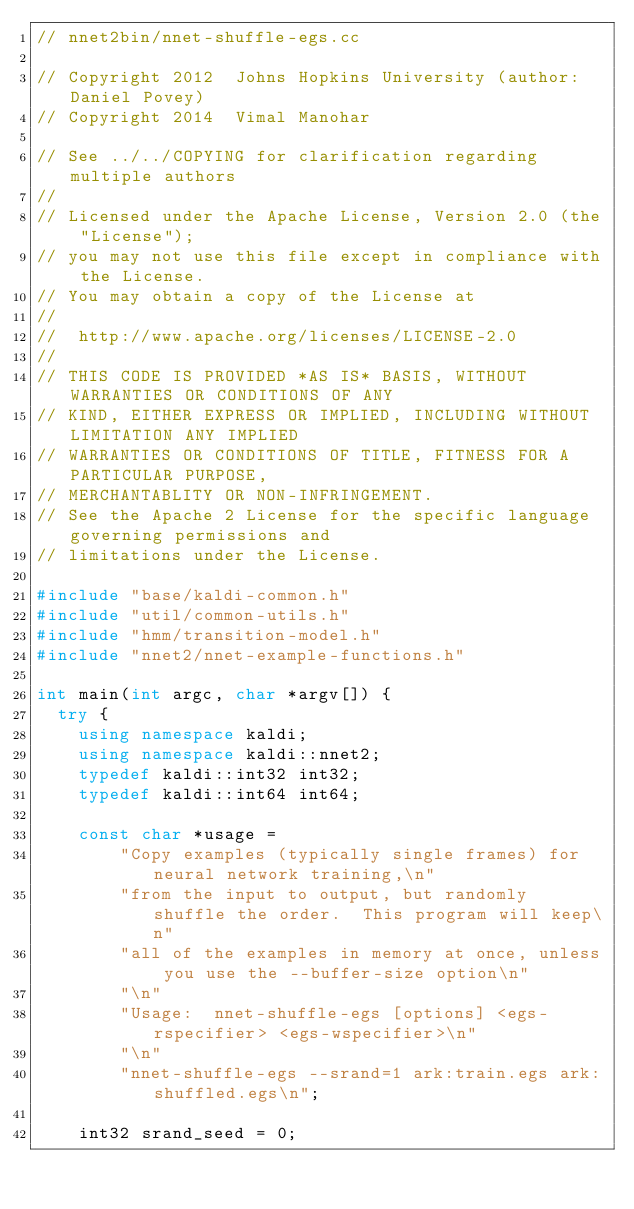<code> <loc_0><loc_0><loc_500><loc_500><_C++_>// nnet2bin/nnet-shuffle-egs.cc

// Copyright 2012  Johns Hopkins University (author:  Daniel Povey)
// Copyright 2014  Vimal Manohar

// See ../../COPYING for clarification regarding multiple authors
//
// Licensed under the Apache License, Version 2.0 (the "License");
// you may not use this file except in compliance with the License.
// You may obtain a copy of the License at
//
//  http://www.apache.org/licenses/LICENSE-2.0
//
// THIS CODE IS PROVIDED *AS IS* BASIS, WITHOUT WARRANTIES OR CONDITIONS OF ANY
// KIND, EITHER EXPRESS OR IMPLIED, INCLUDING WITHOUT LIMITATION ANY IMPLIED
// WARRANTIES OR CONDITIONS OF TITLE, FITNESS FOR A PARTICULAR PURPOSE,
// MERCHANTABLITY OR NON-INFRINGEMENT.
// See the Apache 2 License for the specific language governing permissions and
// limitations under the License.

#include "base/kaldi-common.h"
#include "util/common-utils.h"
#include "hmm/transition-model.h"
#include "nnet2/nnet-example-functions.h"

int main(int argc, char *argv[]) {
  try {
    using namespace kaldi;
    using namespace kaldi::nnet2;
    typedef kaldi::int32 int32;
    typedef kaldi::int64 int64;

    const char *usage =
        "Copy examples (typically single frames) for neural network training,\n"
        "from the input to output, but randomly shuffle the order.  This program will keep\n"
        "all of the examples in memory at once, unless you use the --buffer-size option\n"
        "\n"
        "Usage:  nnet-shuffle-egs [options] <egs-rspecifier> <egs-wspecifier>\n"
        "\n"
        "nnet-shuffle-egs --srand=1 ark:train.egs ark:shuffled.egs\n";

    int32 srand_seed = 0;</code> 